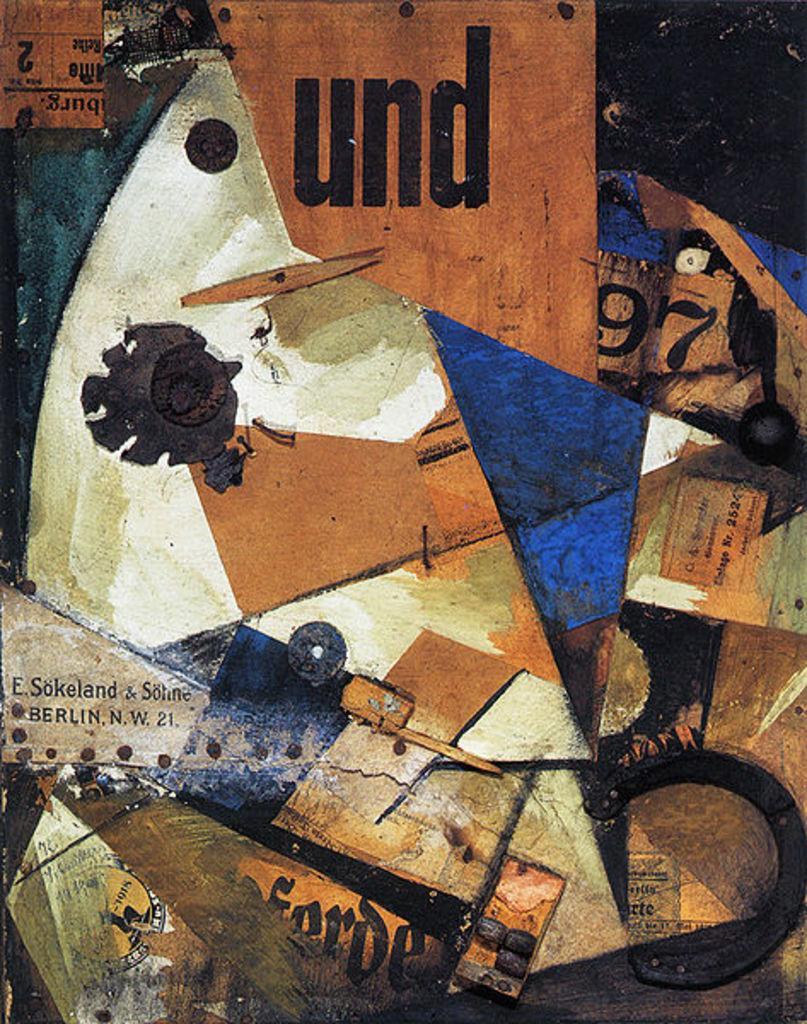Could you give a brief overview of what you see in this image? In this picture I can see words, numbers and there is a painting on an object. 